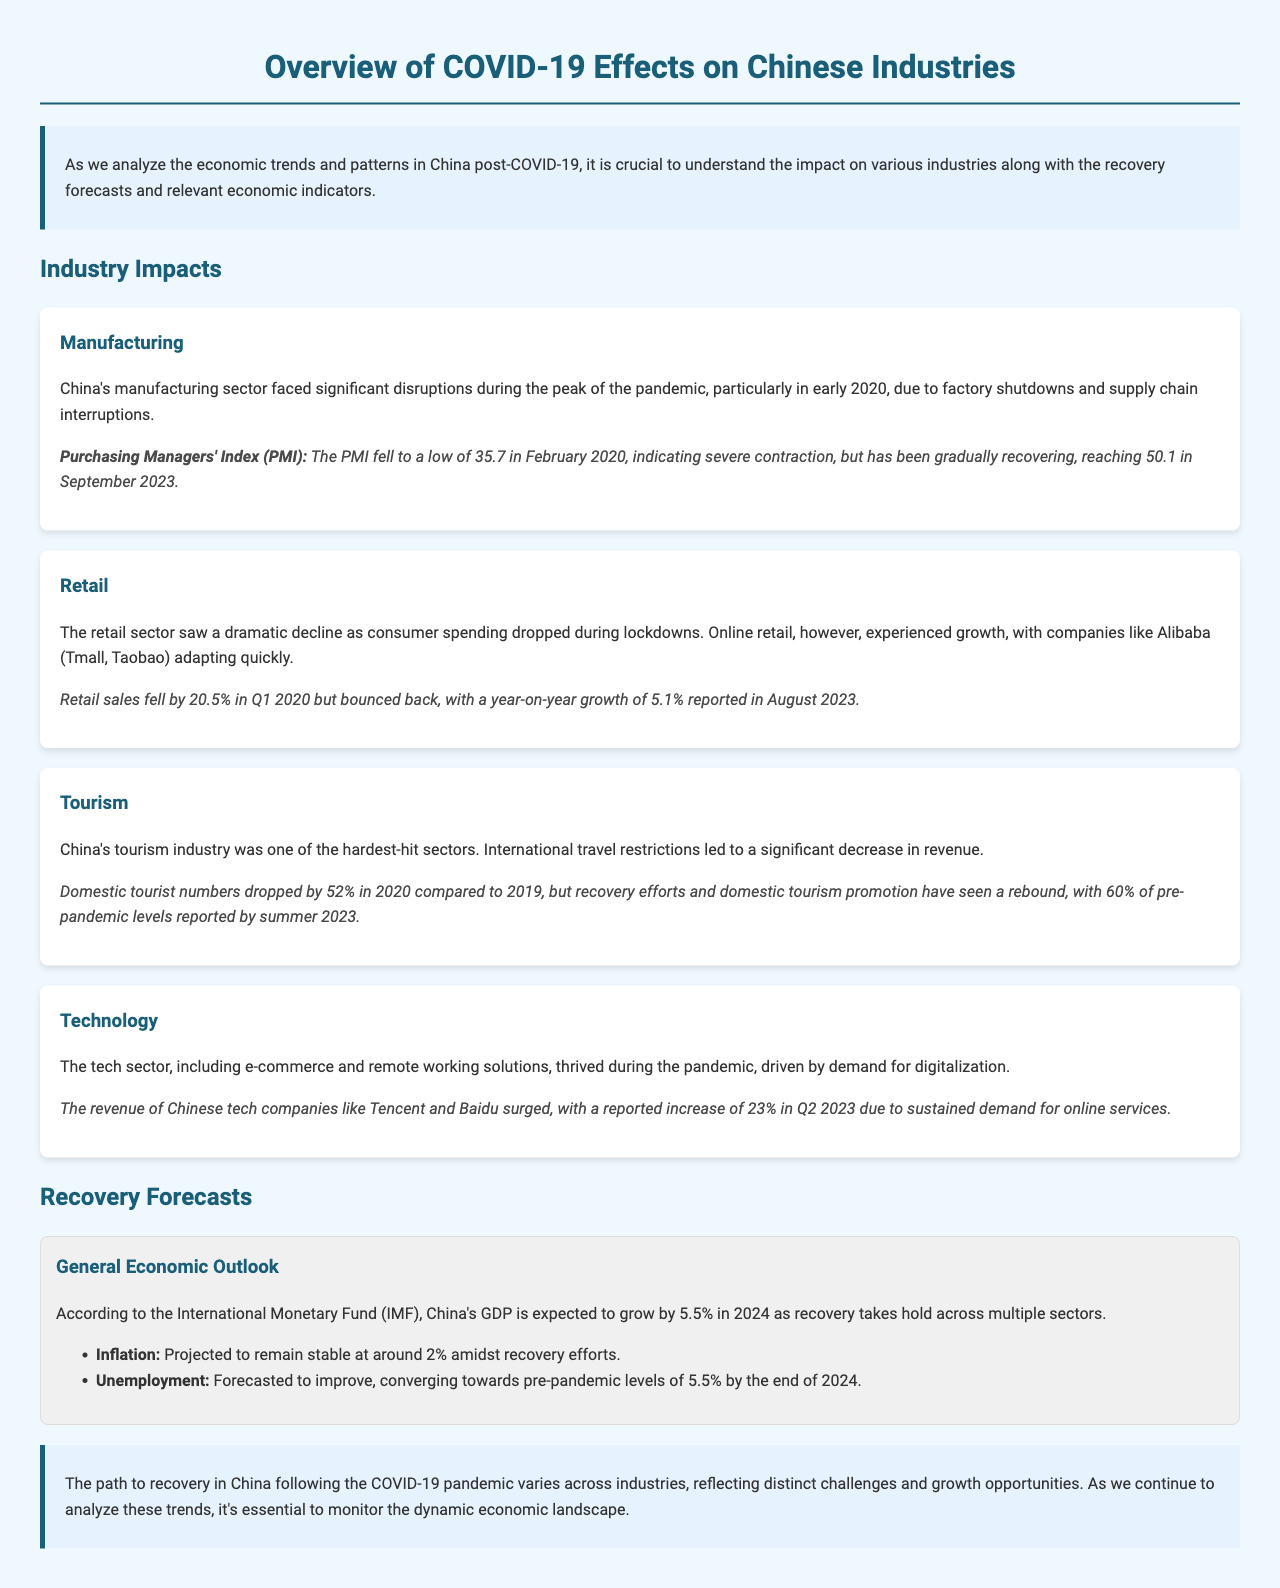What was the PMI in February 2020? The Purchasing Managers' Index dropped to a low of 35.7 in February 2020, indicating severe contraction.
Answer: 35.7 What sector showed a year-on-year growth of 5.1% in August 2023? The retail sector experienced a year-on-year growth of 5.1% in August 2023.
Answer: Retail By what percentage did domestic tourist numbers drop in 2020 compared to 2019? Domestic tourist numbers dropped by 52% in 2020 compared to 2019.
Answer: 52% What was the forecasted GDP growth for China in 2024? According to the International Monetary Fund, China's GDP is expected to grow by 5.5% in 2024.
Answer: 5.5% What percentage of pre-pandemic levels did domestic tourism reach by summer 2023? Domestic tourism reached 60% of pre-pandemic levels by summer 2023.
Answer: 60% What revenue increase did Tencent and Baidu report in Q2 2023? Chinese tech companies like Tencent and Baidu reported a revenue increase of 23% in Q2 2023.
Answer: 23% What is projected to remain stable at around 2%? Inflation is projected to remain stable at around 2% amidst recovery efforts.
Answer: 2% What was the unemployment forecast by the end of 2024? The unemployment rate is forecasted to converge towards pre-pandemic levels of 5.5% by the end of 2024.
Answer: 5.5% What impact did the pandemic have on the manufacturing sector? The manufacturing sector faced significant disruptions during the peak of the pandemic, with factory shutdowns and supply chain interruptions.
Answer: Significant disruptions 